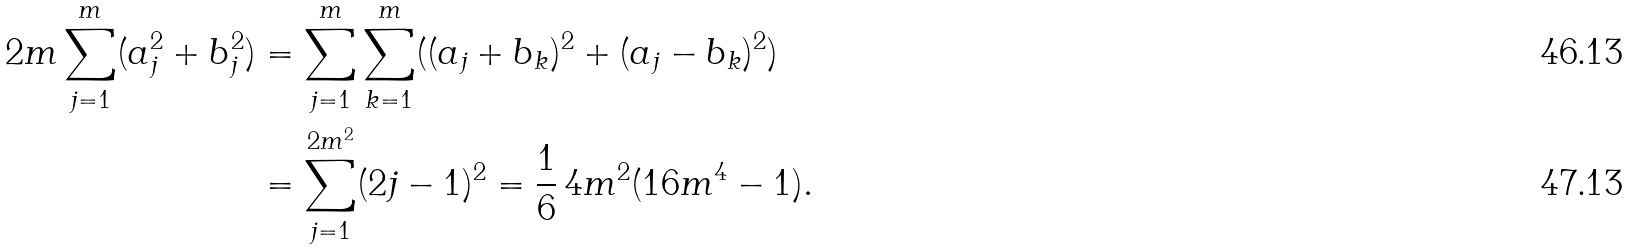<formula> <loc_0><loc_0><loc_500><loc_500>2 m \sum _ { j = 1 } ^ { m } ( a _ { j } ^ { 2 } + b _ { j } ^ { 2 } ) & = \sum _ { j = 1 } ^ { m } \sum _ { k = 1 } ^ { m } ( ( a _ { j } + b _ { k } ) ^ { 2 } + ( a _ { j } - b _ { k } ) ^ { 2 } ) \\ & = \sum _ { j = 1 } ^ { 2 m ^ { 2 } } ( 2 j - 1 ) ^ { 2 } = \frac { 1 } { 6 } \, 4 m ^ { 2 } ( 1 6 m ^ { 4 } - 1 ) .</formula> 